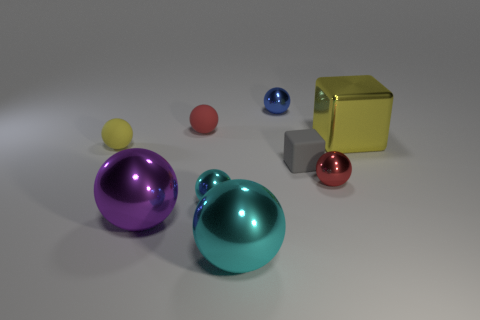What size is the red rubber object?
Give a very brief answer. Small. The gray rubber object has what shape?
Keep it short and to the point. Cube. Is the color of the tiny sphere that is to the right of the blue shiny object the same as the matte cube?
Your answer should be compact. No. What is the size of the matte thing that is the same shape as the yellow metallic thing?
Give a very brief answer. Small. There is a yellow thing to the right of the tiny red object in front of the yellow matte ball; is there a big yellow object that is behind it?
Offer a terse response. No. What material is the cyan sphere that is right of the tiny cyan metallic ball?
Offer a very short reply. Metal. What number of big objects are either yellow shiny cubes or yellow matte balls?
Ensure brevity in your answer.  1. Does the ball right of the blue thing have the same size as the tiny gray rubber block?
Your answer should be compact. Yes. What number of other objects are there of the same color as the large block?
Your answer should be very brief. 1. What is the material of the big purple sphere?
Give a very brief answer. Metal. 